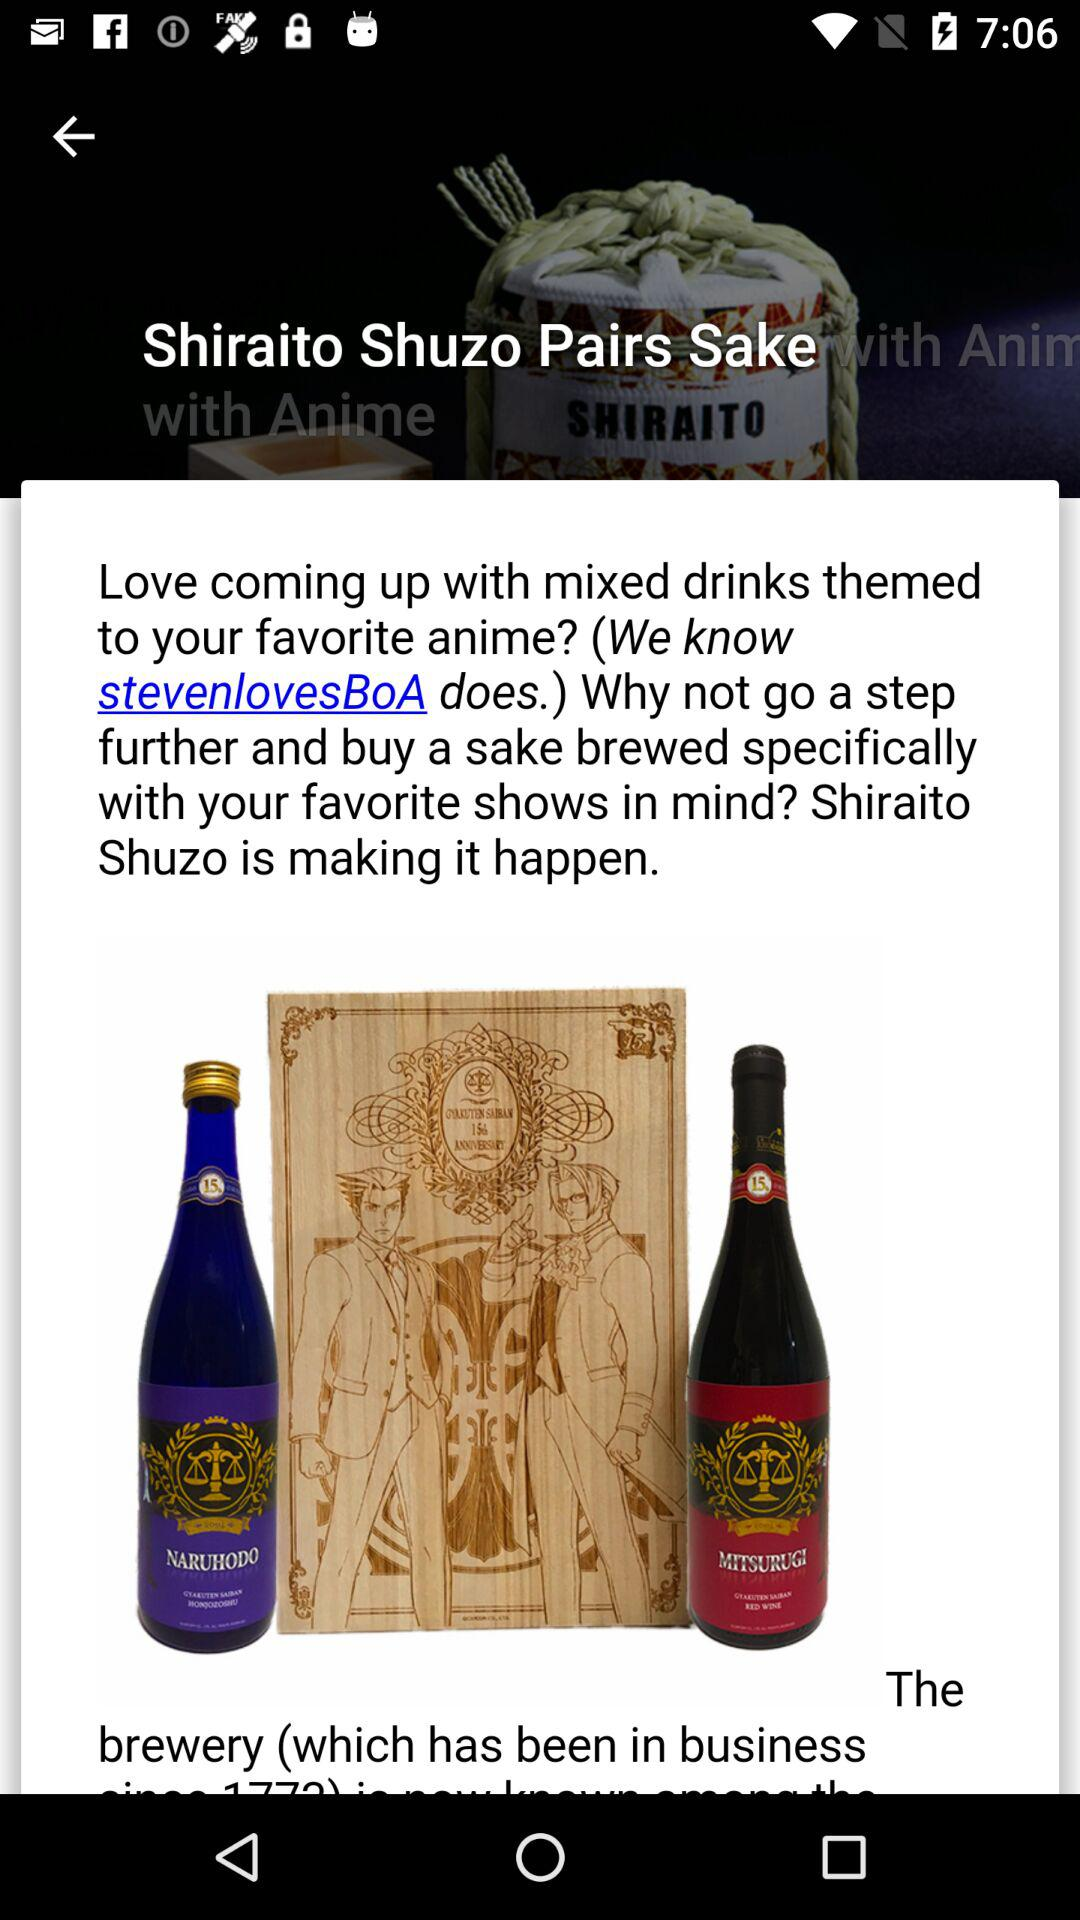How much does the sake cost?
When the provided information is insufficient, respond with <no answer>. <no answer> 